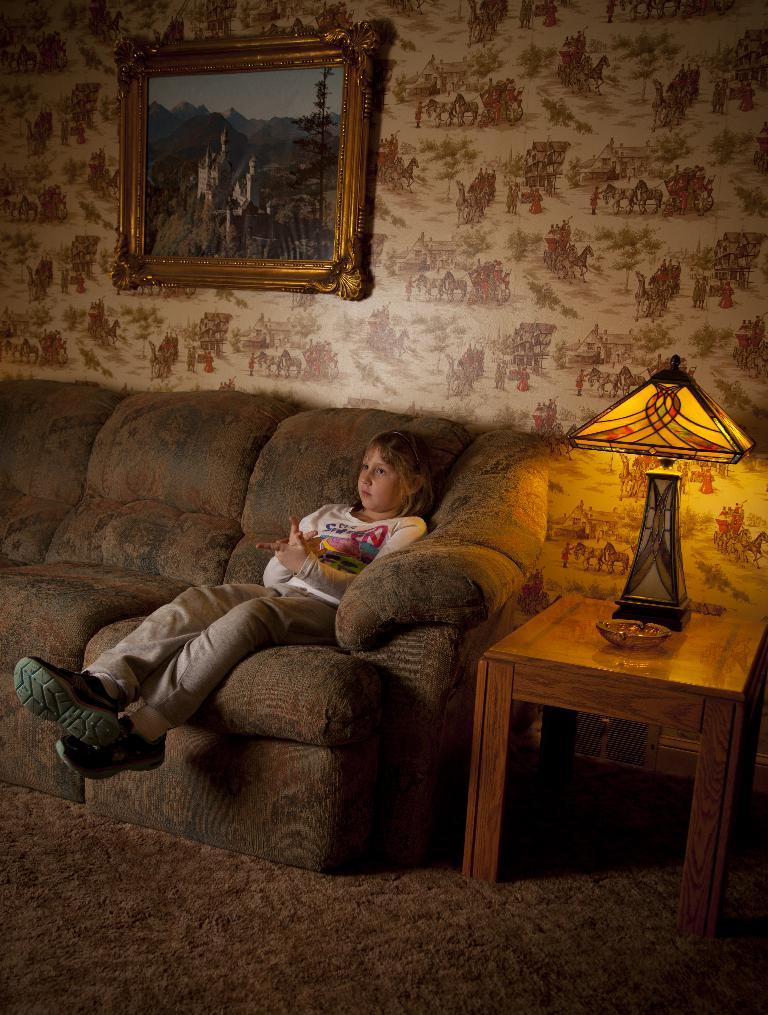What is the main subject in the image? There is a small girl sitting on the couch. What can be seen on the table in the image? There is a lamp and a small bowl on the table. What is hanging on the wall in the image? There is a photo frame attached to the wall. What part of the room is visible in the image? The floor is visible in the image. What type of rod is used to hold the photo frame in the image? There is no rod visible in the image; the photo frame is attached to the wall using an unspecified method. 